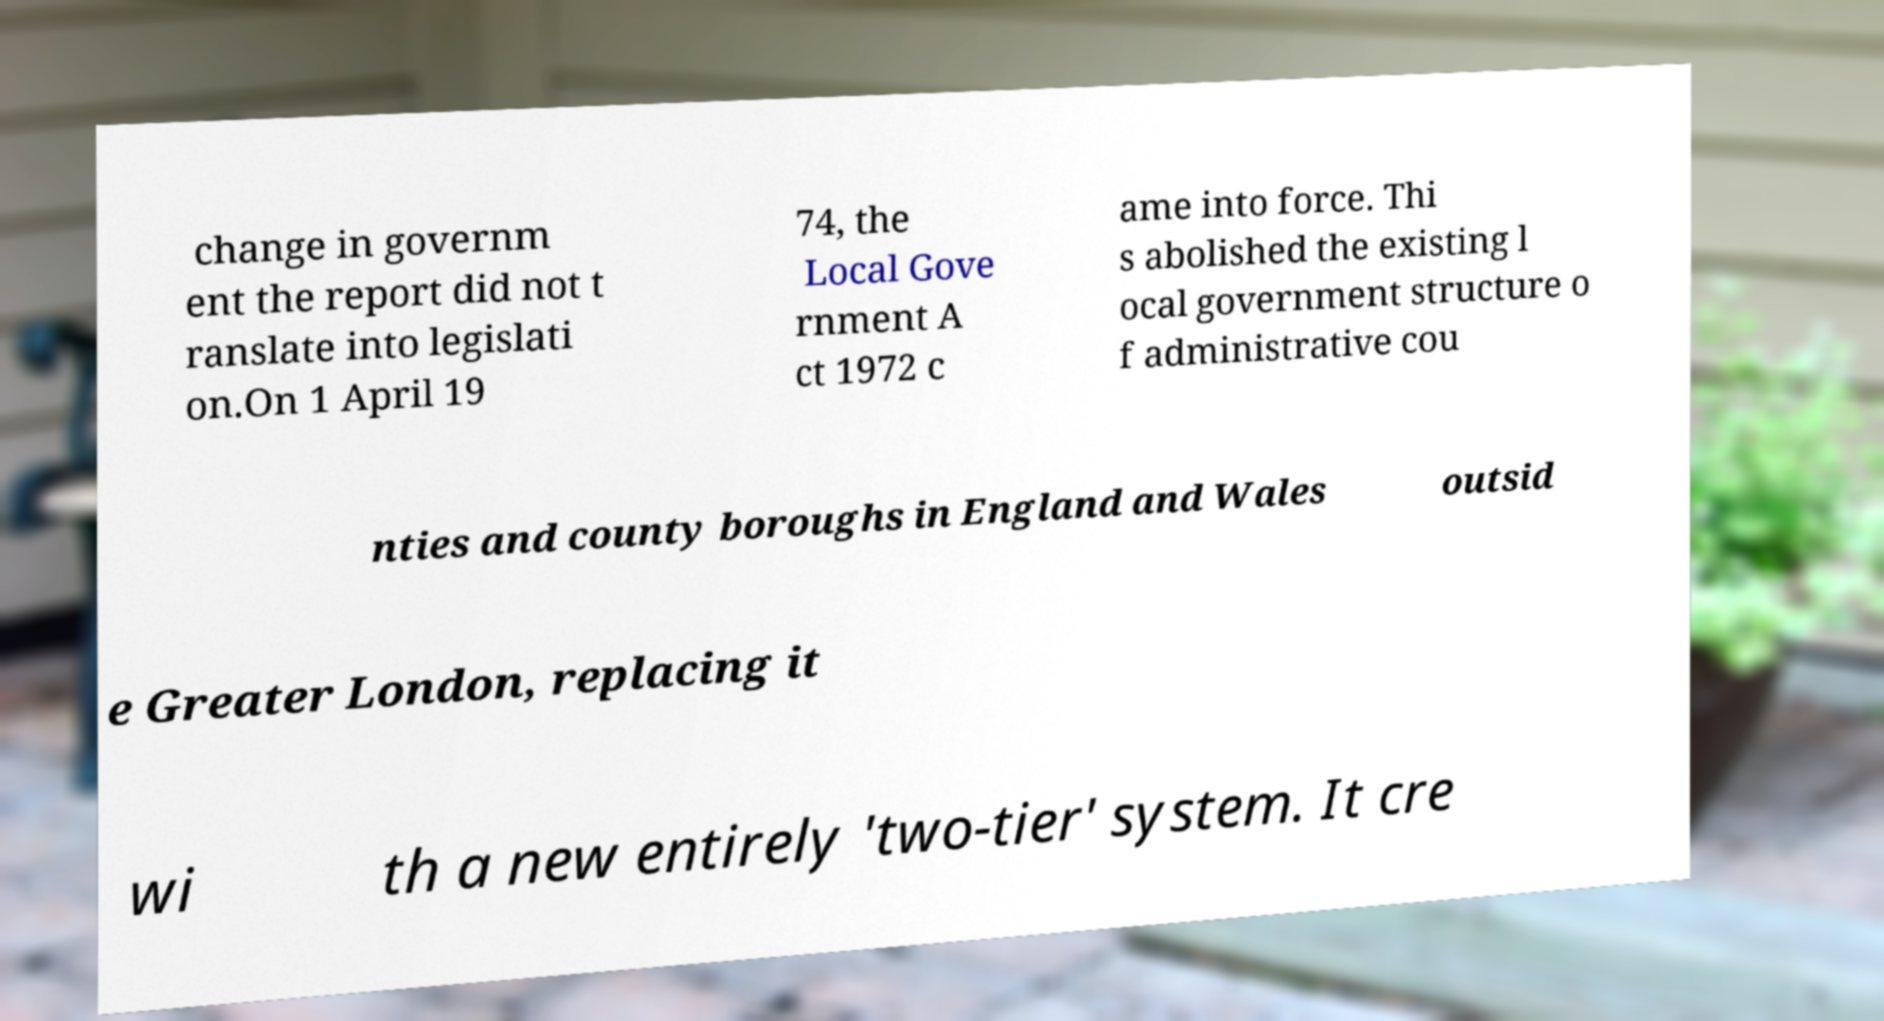Can you accurately transcribe the text from the provided image for me? change in governm ent the report did not t ranslate into legislati on.On 1 April 19 74, the Local Gove rnment A ct 1972 c ame into force. Thi s abolished the existing l ocal government structure o f administrative cou nties and county boroughs in England and Wales outsid e Greater London, replacing it wi th a new entirely 'two-tier' system. It cre 